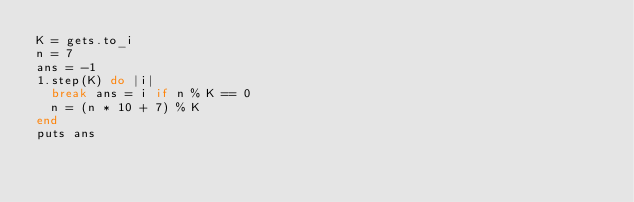<code> <loc_0><loc_0><loc_500><loc_500><_Ruby_>K = gets.to_i
n = 7
ans = -1
1.step(K) do |i|
  break ans = i if n % K == 0
  n = (n * 10 + 7) % K
end
puts ans</code> 